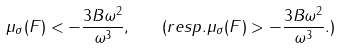Convert formula to latex. <formula><loc_0><loc_0><loc_500><loc_500>\mu _ { \sigma } ( F ) < - \frac { 3 B \omega ^ { 2 } } { \omega ^ { 3 } } , \quad ( r e s p . \mu _ { \sigma } ( F ) > - \frac { 3 B \omega ^ { 2 } } { \omega ^ { 3 } } . )</formula> 